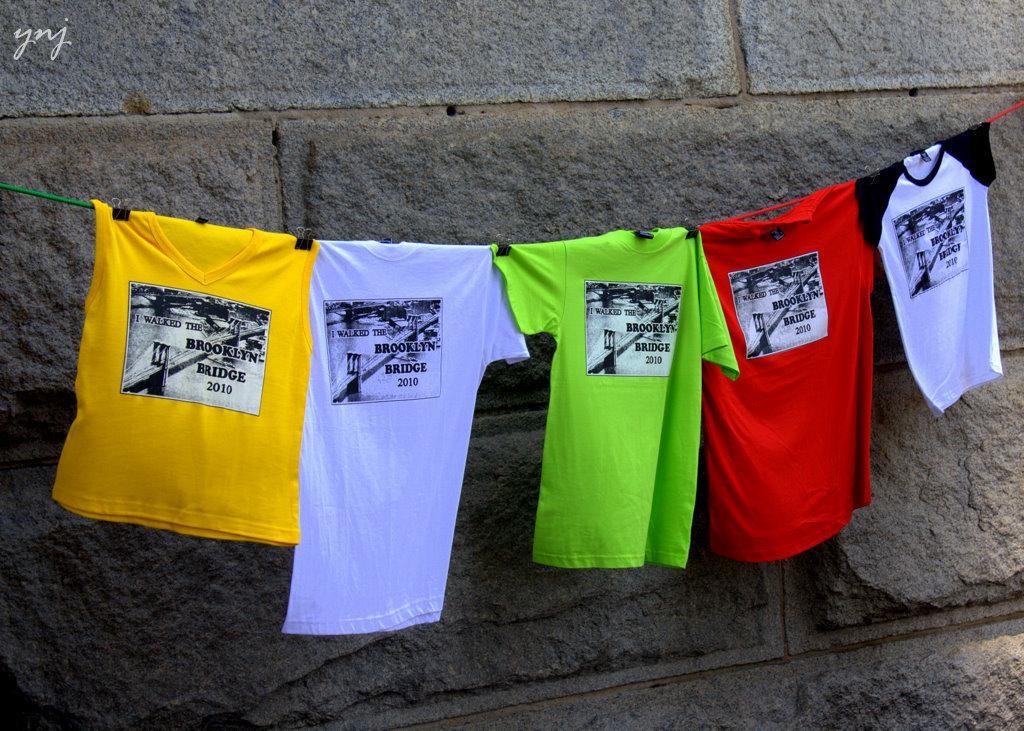In one or two sentences, can you explain what this image depicts? In the center of the picture there are t-shirt on a rope. The t-shirts are of different colors. In the background there is a wall. 